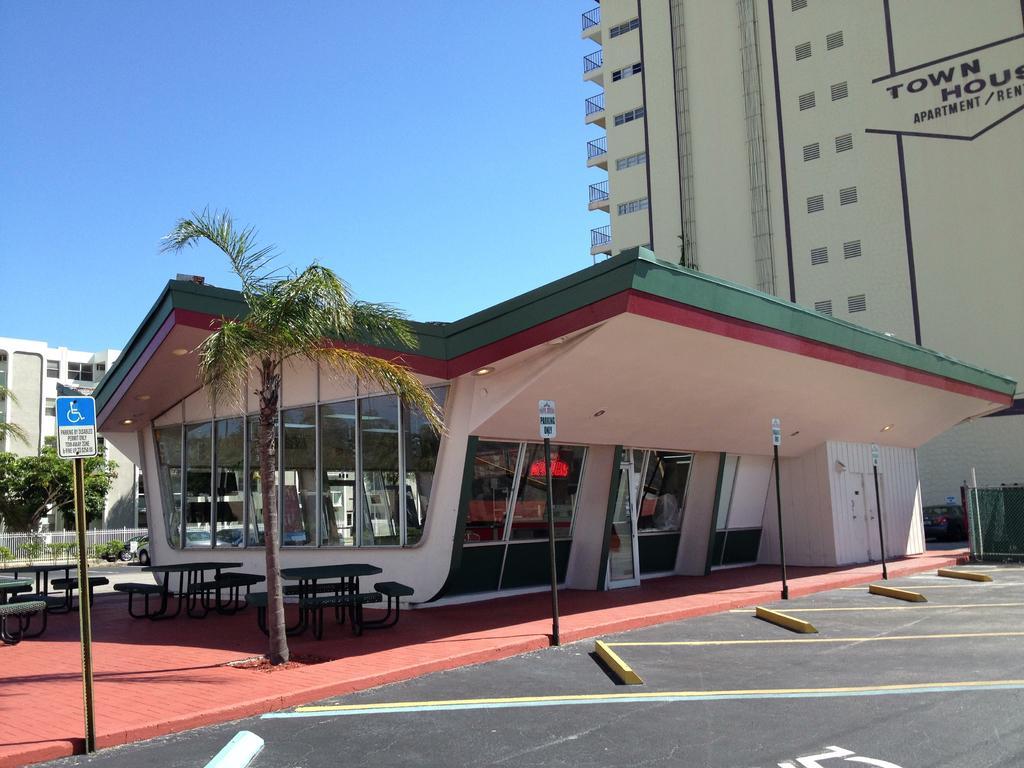Please provide a concise description of this image. In this image we can see few buildings, some text on the building, there are few benches, poles with board, few trees, fence, vehicles on the road and the sky in the background. 